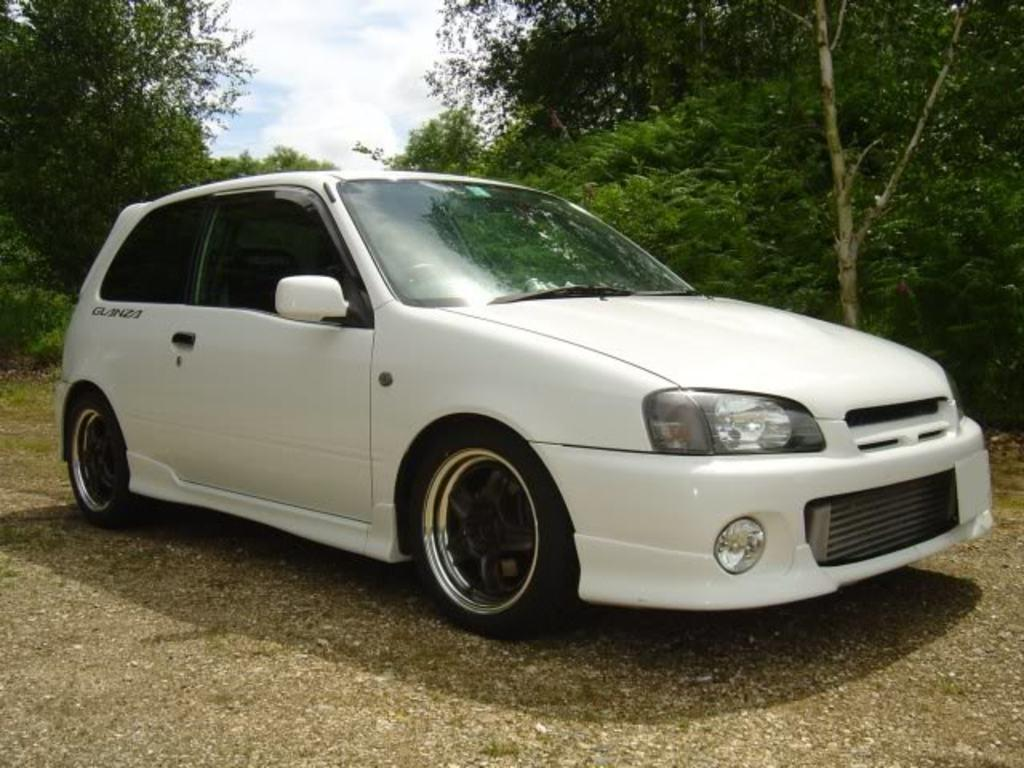What is the main subject of the image? There is a car on the road in the image. What can be seen in the background of the image? Trees and the sky are visible in the image. What is the condition of the sky in the image? Clouds are present in the sky. How long has the car been sleeping in the image? There is no indication that the car is sleeping in the image, as cars do not have the ability to sleep. 